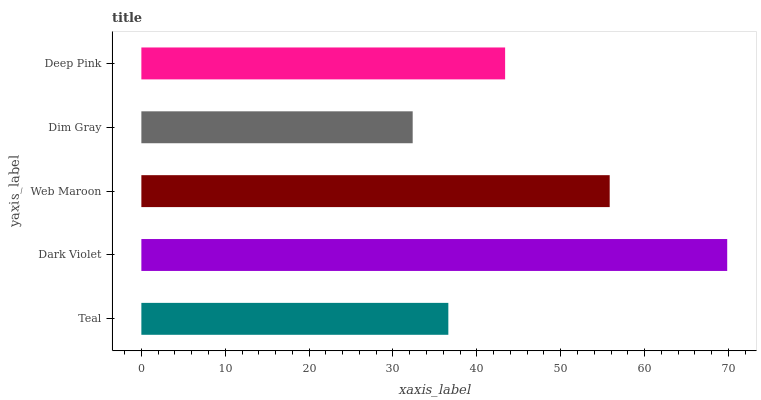Is Dim Gray the minimum?
Answer yes or no. Yes. Is Dark Violet the maximum?
Answer yes or no. Yes. Is Web Maroon the minimum?
Answer yes or no. No. Is Web Maroon the maximum?
Answer yes or no. No. Is Dark Violet greater than Web Maroon?
Answer yes or no. Yes. Is Web Maroon less than Dark Violet?
Answer yes or no. Yes. Is Web Maroon greater than Dark Violet?
Answer yes or no. No. Is Dark Violet less than Web Maroon?
Answer yes or no. No. Is Deep Pink the high median?
Answer yes or no. Yes. Is Deep Pink the low median?
Answer yes or no. Yes. Is Teal the high median?
Answer yes or no. No. Is Dark Violet the low median?
Answer yes or no. No. 